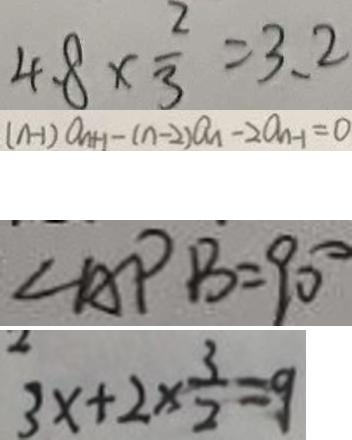<formula> <loc_0><loc_0><loc_500><loc_500>4 . 8 \times \frac { 2 } { 3 } = 3 . 2 
 ( n - 1 ) a _ { n + 1 } - ( n - 2 ) a _ { 1 } - 2 a _ { n - 1 } = 0 
 \angle A P B = 9 0 ^ { \circ } 
 3 x + 2 \times \frac { 3 } { 2 } = 9</formula> 